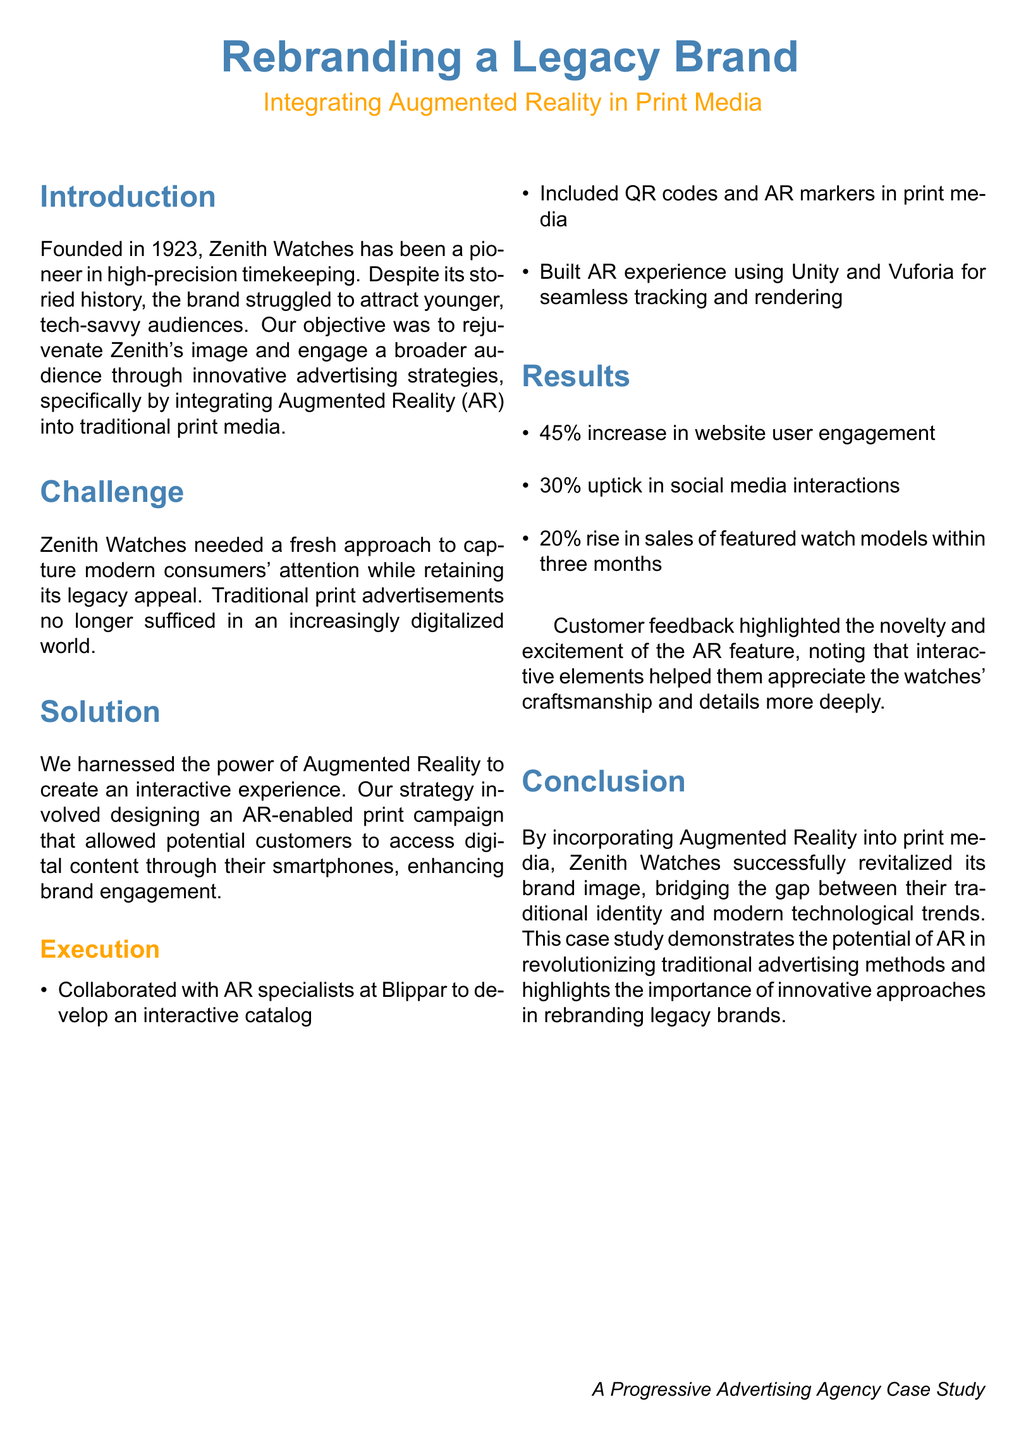What year was Zenith Watches founded? The document states that Zenith Watches was founded in 1923.
Answer: 1923 What technology was integrated into the print media for the campaign? The document mentions that Augmented Reality was integrated into the print media.
Answer: Augmented Reality What was the percentage increase in website user engagement? The document specifies a 45% increase in website user engagement as a result of the campaign.
Answer: 45% Who did Zenith collaborate with to develop the interactive catalog? The document states that Zenith collaborated with AR specialists at Blippar.
Answer: Blippar What was the percentage rise in sales of featured watch models within three months? The document indicates a 20% rise in sales of featured watch models within three months.
Answer: 20% What was the primary challenge faced by Zenith Watches? The document describes the primary challenge as needing a fresh approach to capture modern consumers' attention.
Answer: Fresh approach What was the outcome in terms of social media interactions? According to the document, there was a 30% uptick in social media interactions.
Answer: 30% What core objective did the case study aim to achieve? The document states the objective was to rejuvenate Zenith's image and engage a broader audience.
Answer: Rejuvenate image How did customers feel about the AR feature based on feedback? The document describes customer feedback highlighting the novelty and excitement of the AR feature.
Answer: Novelty and excitement What type of document is this? The document is a case study focused on rebranding a legacy brand using innovative advertising strategies.
Answer: Case study 